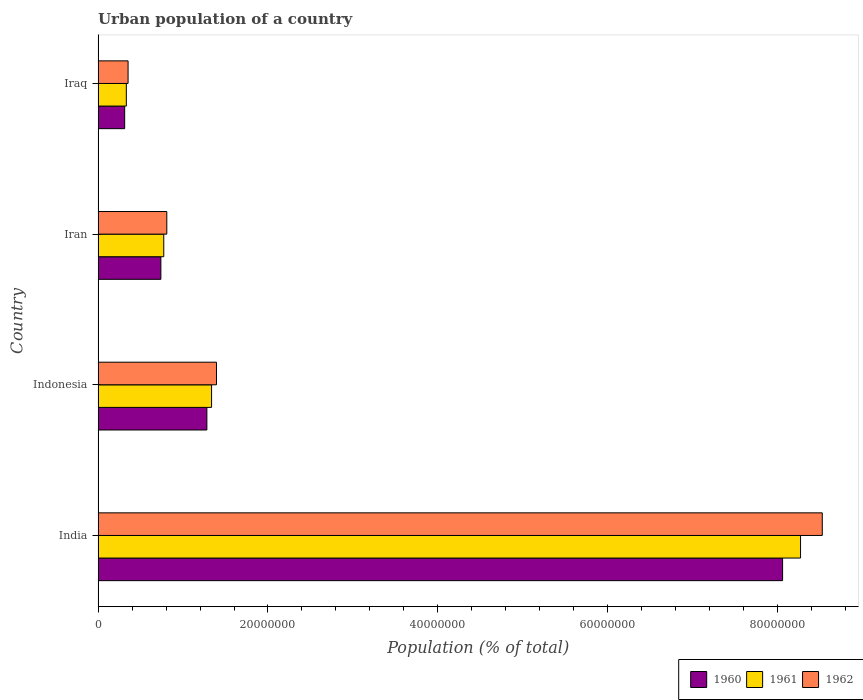Are the number of bars per tick equal to the number of legend labels?
Make the answer very short. Yes. How many bars are there on the 3rd tick from the top?
Give a very brief answer. 3. How many bars are there on the 4th tick from the bottom?
Your answer should be compact. 3. In how many cases, is the number of bars for a given country not equal to the number of legend labels?
Give a very brief answer. 0. What is the urban population in 1960 in Iraq?
Offer a very short reply. 3.13e+06. Across all countries, what is the maximum urban population in 1962?
Provide a succinct answer. 8.53e+07. Across all countries, what is the minimum urban population in 1962?
Provide a succinct answer. 3.53e+06. In which country was the urban population in 1960 maximum?
Provide a short and direct response. India. In which country was the urban population in 1961 minimum?
Your answer should be compact. Iraq. What is the total urban population in 1960 in the graph?
Offer a very short reply. 1.04e+08. What is the difference between the urban population in 1960 in Indonesia and that in Iraq?
Your answer should be compact. 9.68e+06. What is the difference between the urban population in 1960 in Iraq and the urban population in 1962 in Iran?
Offer a very short reply. -4.96e+06. What is the average urban population in 1962 per country?
Give a very brief answer. 2.77e+07. What is the difference between the urban population in 1961 and urban population in 1962 in Indonesia?
Give a very brief answer. -5.78e+05. What is the ratio of the urban population in 1962 in Indonesia to that in Iran?
Your answer should be compact. 1.72. Is the difference between the urban population in 1961 in Indonesia and Iran greater than the difference between the urban population in 1962 in Indonesia and Iran?
Keep it short and to the point. No. What is the difference between the highest and the second highest urban population in 1960?
Your response must be concise. 6.78e+07. What is the difference between the highest and the lowest urban population in 1962?
Provide a succinct answer. 8.17e+07. What does the 1st bar from the top in Iran represents?
Ensure brevity in your answer.  1962. Is it the case that in every country, the sum of the urban population in 1960 and urban population in 1962 is greater than the urban population in 1961?
Ensure brevity in your answer.  Yes. How many bars are there?
Provide a short and direct response. 12. What is the difference between two consecutive major ticks on the X-axis?
Your answer should be very brief. 2.00e+07. Are the values on the major ticks of X-axis written in scientific E-notation?
Your response must be concise. No. Does the graph contain any zero values?
Make the answer very short. No. What is the title of the graph?
Your answer should be compact. Urban population of a country. Does "2001" appear as one of the legend labels in the graph?
Keep it short and to the point. No. What is the label or title of the X-axis?
Make the answer very short. Population (% of total). What is the label or title of the Y-axis?
Make the answer very short. Country. What is the Population (% of total) in 1960 in India?
Offer a terse response. 8.06e+07. What is the Population (% of total) of 1961 in India?
Your response must be concise. 8.27e+07. What is the Population (% of total) of 1962 in India?
Ensure brevity in your answer.  8.53e+07. What is the Population (% of total) of 1960 in Indonesia?
Provide a succinct answer. 1.28e+07. What is the Population (% of total) of 1961 in Indonesia?
Your response must be concise. 1.34e+07. What is the Population (% of total) of 1962 in Indonesia?
Give a very brief answer. 1.39e+07. What is the Population (% of total) in 1960 in Iran?
Your response must be concise. 7.39e+06. What is the Population (% of total) of 1961 in Iran?
Give a very brief answer. 7.73e+06. What is the Population (% of total) of 1962 in Iran?
Ensure brevity in your answer.  8.09e+06. What is the Population (% of total) in 1960 in Iraq?
Provide a short and direct response. 3.13e+06. What is the Population (% of total) in 1961 in Iraq?
Provide a succinct answer. 3.32e+06. What is the Population (% of total) in 1962 in Iraq?
Offer a terse response. 3.53e+06. Across all countries, what is the maximum Population (% of total) of 1960?
Make the answer very short. 8.06e+07. Across all countries, what is the maximum Population (% of total) in 1961?
Provide a short and direct response. 8.27e+07. Across all countries, what is the maximum Population (% of total) of 1962?
Offer a very short reply. 8.53e+07. Across all countries, what is the minimum Population (% of total) of 1960?
Your response must be concise. 3.13e+06. Across all countries, what is the minimum Population (% of total) in 1961?
Ensure brevity in your answer.  3.32e+06. Across all countries, what is the minimum Population (% of total) of 1962?
Ensure brevity in your answer.  3.53e+06. What is the total Population (% of total) in 1960 in the graph?
Provide a succinct answer. 1.04e+08. What is the total Population (% of total) in 1961 in the graph?
Provide a short and direct response. 1.07e+08. What is the total Population (% of total) in 1962 in the graph?
Make the answer very short. 1.11e+08. What is the difference between the Population (% of total) in 1960 in India and that in Indonesia?
Your answer should be compact. 6.78e+07. What is the difference between the Population (% of total) of 1961 in India and that in Indonesia?
Offer a very short reply. 6.94e+07. What is the difference between the Population (% of total) of 1962 in India and that in Indonesia?
Offer a terse response. 7.13e+07. What is the difference between the Population (% of total) in 1960 in India and that in Iran?
Ensure brevity in your answer.  7.32e+07. What is the difference between the Population (% of total) of 1961 in India and that in Iran?
Provide a short and direct response. 7.50e+07. What is the difference between the Population (% of total) in 1962 in India and that in Iran?
Provide a short and direct response. 7.72e+07. What is the difference between the Population (% of total) in 1960 in India and that in Iraq?
Provide a short and direct response. 7.75e+07. What is the difference between the Population (% of total) in 1961 in India and that in Iraq?
Provide a succinct answer. 7.94e+07. What is the difference between the Population (% of total) of 1962 in India and that in Iraq?
Offer a very short reply. 8.17e+07. What is the difference between the Population (% of total) in 1960 in Indonesia and that in Iran?
Offer a terse response. 5.42e+06. What is the difference between the Population (% of total) in 1961 in Indonesia and that in Iran?
Make the answer very short. 5.63e+06. What is the difference between the Population (% of total) in 1962 in Indonesia and that in Iran?
Your answer should be compact. 5.85e+06. What is the difference between the Population (% of total) in 1960 in Indonesia and that in Iraq?
Offer a very short reply. 9.68e+06. What is the difference between the Population (% of total) of 1961 in Indonesia and that in Iraq?
Your answer should be very brief. 1.00e+07. What is the difference between the Population (% of total) in 1962 in Indonesia and that in Iraq?
Provide a short and direct response. 1.04e+07. What is the difference between the Population (% of total) in 1960 in Iran and that in Iraq?
Keep it short and to the point. 4.26e+06. What is the difference between the Population (% of total) of 1961 in Iran and that in Iraq?
Offer a very short reply. 4.41e+06. What is the difference between the Population (% of total) of 1962 in Iran and that in Iraq?
Your response must be concise. 4.56e+06. What is the difference between the Population (% of total) of 1960 in India and the Population (% of total) of 1961 in Indonesia?
Keep it short and to the point. 6.72e+07. What is the difference between the Population (% of total) of 1960 in India and the Population (% of total) of 1962 in Indonesia?
Your answer should be compact. 6.67e+07. What is the difference between the Population (% of total) of 1961 in India and the Population (% of total) of 1962 in Indonesia?
Your answer should be compact. 6.88e+07. What is the difference between the Population (% of total) in 1960 in India and the Population (% of total) in 1961 in Iran?
Provide a short and direct response. 7.29e+07. What is the difference between the Population (% of total) of 1960 in India and the Population (% of total) of 1962 in Iran?
Ensure brevity in your answer.  7.25e+07. What is the difference between the Population (% of total) in 1961 in India and the Population (% of total) in 1962 in Iran?
Offer a terse response. 7.46e+07. What is the difference between the Population (% of total) of 1960 in India and the Population (% of total) of 1961 in Iraq?
Your answer should be very brief. 7.73e+07. What is the difference between the Population (% of total) in 1960 in India and the Population (% of total) in 1962 in Iraq?
Provide a short and direct response. 7.71e+07. What is the difference between the Population (% of total) in 1961 in India and the Population (% of total) in 1962 in Iraq?
Offer a very short reply. 7.92e+07. What is the difference between the Population (% of total) in 1960 in Indonesia and the Population (% of total) in 1961 in Iran?
Ensure brevity in your answer.  5.07e+06. What is the difference between the Population (% of total) of 1960 in Indonesia and the Population (% of total) of 1962 in Iran?
Offer a terse response. 4.72e+06. What is the difference between the Population (% of total) of 1961 in Indonesia and the Population (% of total) of 1962 in Iran?
Make the answer very short. 5.27e+06. What is the difference between the Population (% of total) in 1960 in Indonesia and the Population (% of total) in 1961 in Iraq?
Ensure brevity in your answer.  9.48e+06. What is the difference between the Population (% of total) in 1960 in Indonesia and the Population (% of total) in 1962 in Iraq?
Offer a very short reply. 9.28e+06. What is the difference between the Population (% of total) in 1961 in Indonesia and the Population (% of total) in 1962 in Iraq?
Offer a terse response. 9.83e+06. What is the difference between the Population (% of total) in 1960 in Iran and the Population (% of total) in 1961 in Iraq?
Your response must be concise. 4.07e+06. What is the difference between the Population (% of total) of 1960 in Iran and the Population (% of total) of 1962 in Iraq?
Keep it short and to the point. 3.86e+06. What is the difference between the Population (% of total) in 1961 in Iran and the Population (% of total) in 1962 in Iraq?
Your answer should be very brief. 4.20e+06. What is the average Population (% of total) in 1960 per country?
Offer a terse response. 2.60e+07. What is the average Population (% of total) in 1961 per country?
Ensure brevity in your answer.  2.68e+07. What is the average Population (% of total) in 1962 per country?
Give a very brief answer. 2.77e+07. What is the difference between the Population (% of total) in 1960 and Population (% of total) in 1961 in India?
Ensure brevity in your answer.  -2.11e+06. What is the difference between the Population (% of total) of 1960 and Population (% of total) of 1962 in India?
Provide a succinct answer. -4.67e+06. What is the difference between the Population (% of total) in 1961 and Population (% of total) in 1962 in India?
Offer a very short reply. -2.56e+06. What is the difference between the Population (% of total) of 1960 and Population (% of total) of 1961 in Indonesia?
Offer a terse response. -5.54e+05. What is the difference between the Population (% of total) of 1960 and Population (% of total) of 1962 in Indonesia?
Provide a short and direct response. -1.13e+06. What is the difference between the Population (% of total) of 1961 and Population (% of total) of 1962 in Indonesia?
Your answer should be very brief. -5.78e+05. What is the difference between the Population (% of total) in 1960 and Population (% of total) in 1961 in Iran?
Provide a succinct answer. -3.40e+05. What is the difference between the Population (% of total) in 1960 and Population (% of total) in 1962 in Iran?
Your response must be concise. -6.96e+05. What is the difference between the Population (% of total) of 1961 and Population (% of total) of 1962 in Iran?
Ensure brevity in your answer.  -3.56e+05. What is the difference between the Population (% of total) of 1960 and Population (% of total) of 1961 in Iraq?
Your answer should be compact. -1.94e+05. What is the difference between the Population (% of total) of 1960 and Population (% of total) of 1962 in Iraq?
Make the answer very short. -4.01e+05. What is the difference between the Population (% of total) of 1961 and Population (% of total) of 1962 in Iraq?
Provide a short and direct response. -2.07e+05. What is the ratio of the Population (% of total) in 1960 in India to that in Indonesia?
Your response must be concise. 6.29. What is the ratio of the Population (% of total) in 1961 in India to that in Indonesia?
Provide a succinct answer. 6.19. What is the ratio of the Population (% of total) in 1962 in India to that in Indonesia?
Provide a succinct answer. 6.12. What is the ratio of the Population (% of total) of 1960 in India to that in Iran?
Your response must be concise. 10.91. What is the ratio of the Population (% of total) in 1961 in India to that in Iran?
Give a very brief answer. 10.7. What is the ratio of the Population (% of total) in 1962 in India to that in Iran?
Keep it short and to the point. 10.54. What is the ratio of the Population (% of total) of 1960 in India to that in Iraq?
Your answer should be compact. 25.77. What is the ratio of the Population (% of total) in 1961 in India to that in Iraq?
Offer a terse response. 24.9. What is the ratio of the Population (% of total) in 1962 in India to that in Iraq?
Keep it short and to the point. 24.17. What is the ratio of the Population (% of total) in 1960 in Indonesia to that in Iran?
Provide a short and direct response. 1.73. What is the ratio of the Population (% of total) of 1961 in Indonesia to that in Iran?
Give a very brief answer. 1.73. What is the ratio of the Population (% of total) of 1962 in Indonesia to that in Iran?
Offer a terse response. 1.72. What is the ratio of the Population (% of total) of 1960 in Indonesia to that in Iraq?
Your answer should be compact. 4.09. What is the ratio of the Population (% of total) in 1961 in Indonesia to that in Iraq?
Your answer should be very brief. 4.02. What is the ratio of the Population (% of total) of 1962 in Indonesia to that in Iraq?
Your answer should be compact. 3.95. What is the ratio of the Population (% of total) of 1960 in Iran to that in Iraq?
Make the answer very short. 2.36. What is the ratio of the Population (% of total) of 1961 in Iran to that in Iraq?
Provide a succinct answer. 2.33. What is the ratio of the Population (% of total) of 1962 in Iran to that in Iraq?
Your answer should be very brief. 2.29. What is the difference between the highest and the second highest Population (% of total) of 1960?
Your response must be concise. 6.78e+07. What is the difference between the highest and the second highest Population (% of total) in 1961?
Your response must be concise. 6.94e+07. What is the difference between the highest and the second highest Population (% of total) in 1962?
Your response must be concise. 7.13e+07. What is the difference between the highest and the lowest Population (% of total) of 1960?
Provide a short and direct response. 7.75e+07. What is the difference between the highest and the lowest Population (% of total) of 1961?
Your answer should be very brief. 7.94e+07. What is the difference between the highest and the lowest Population (% of total) of 1962?
Give a very brief answer. 8.17e+07. 